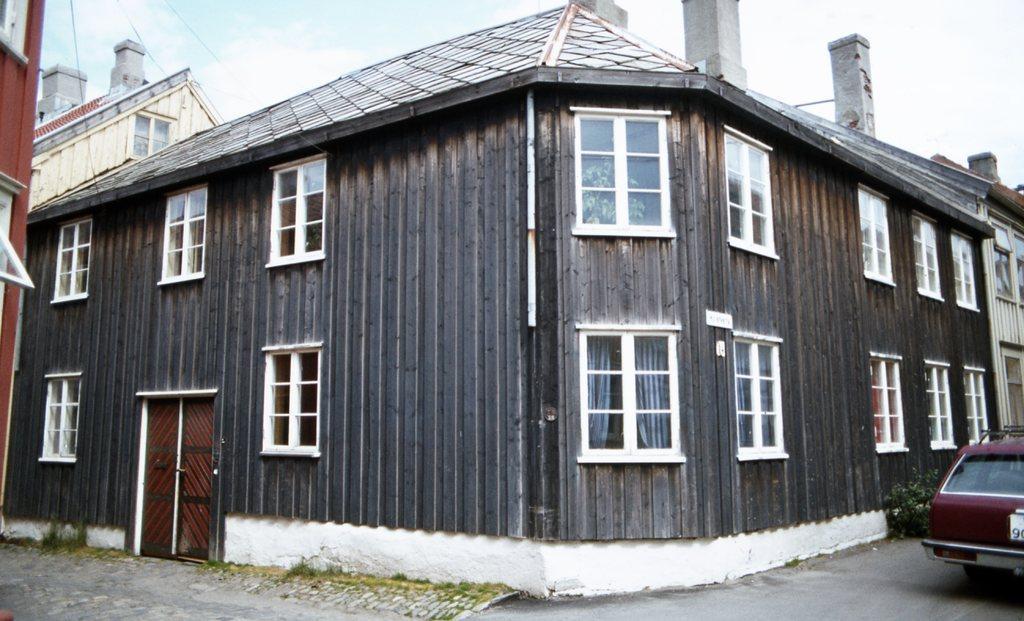Describe this image in one or two sentences. This picture might be taken from outside of the building. In this image, on the right side, we can see a car which is placed on the road. On the left side, we can see a building, glass window. In the middle, we can see a building, door which is closed, glass windows, pillars. At the top, we can see electric wires, sky. 